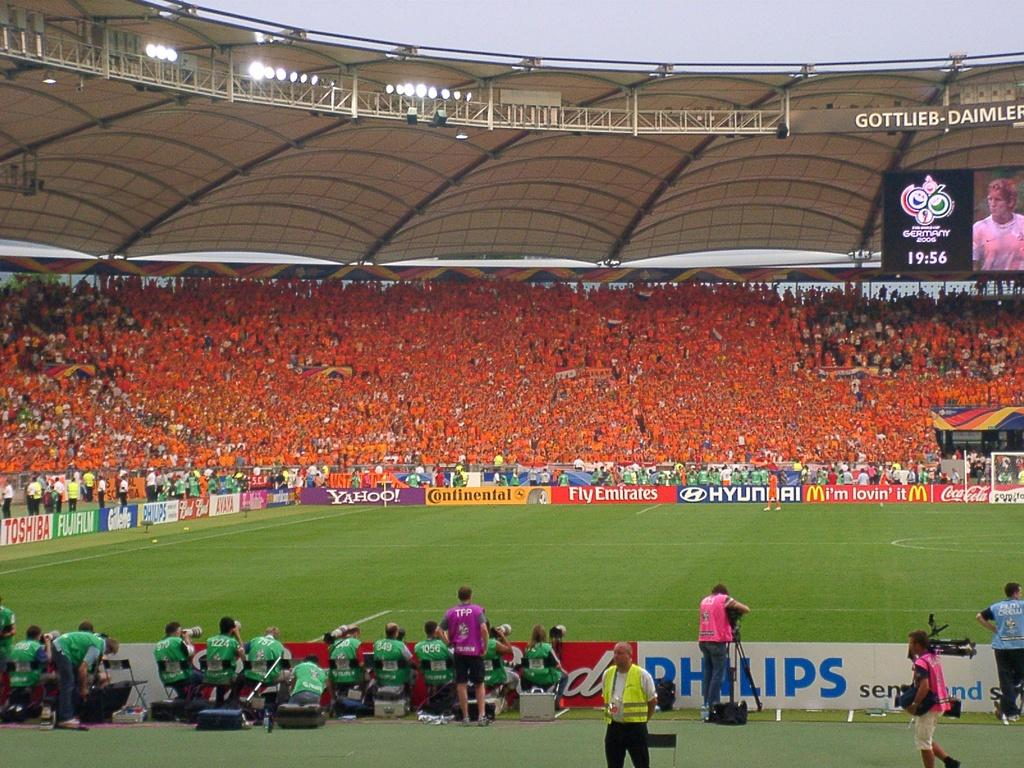Provide a one-sentence caption for the provided image. a soccer stadium with many fans, and advertisements surrounding the pitch, such as hyundai and fly emirates. 